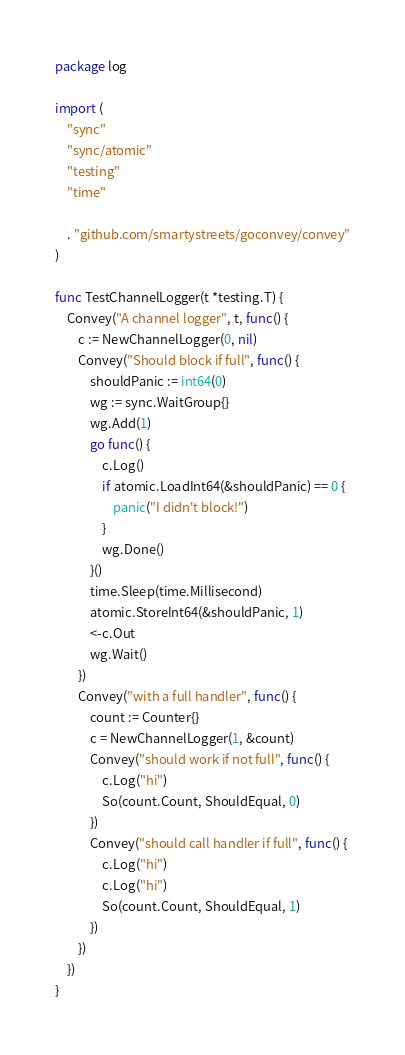Convert code to text. <code><loc_0><loc_0><loc_500><loc_500><_Go_>package log

import (
	"sync"
	"sync/atomic"
	"testing"
	"time"

	. "github.com/smartystreets/goconvey/convey"
)

func TestChannelLogger(t *testing.T) {
	Convey("A channel logger", t, func() {
		c := NewChannelLogger(0, nil)
		Convey("Should block if full", func() {
			shouldPanic := int64(0)
			wg := sync.WaitGroup{}
			wg.Add(1)
			go func() {
				c.Log()
				if atomic.LoadInt64(&shouldPanic) == 0 {
					panic("I didn't block!")
				}
				wg.Done()
			}()
			time.Sleep(time.Millisecond)
			atomic.StoreInt64(&shouldPanic, 1)
			<-c.Out
			wg.Wait()
		})
		Convey("with a full handler", func() {
			count := Counter{}
			c = NewChannelLogger(1, &count)
			Convey("should work if not full", func() {
				c.Log("hi")
				So(count.Count, ShouldEqual, 0)
			})
			Convey("should call handler if full", func() {
				c.Log("hi")
				c.Log("hi")
				So(count.Count, ShouldEqual, 1)
			})
		})
	})
}
</code> 